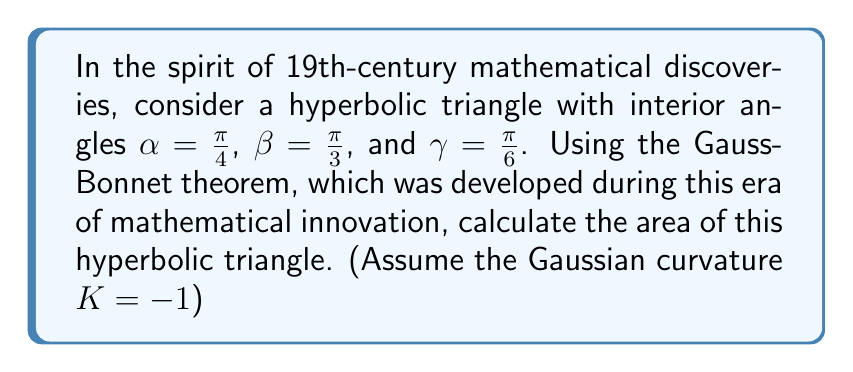Can you answer this question? Let's approach this step-by-step using the Gauss-Bonnet theorem:

1) The Gauss-Bonnet theorem for a hyperbolic triangle states:

   $$A + \alpha + \beta + \gamma = \pi - |K|A$$

   Where $A$ is the area of the triangle, $\alpha$, $\beta$, and $\gamma$ are the interior angles, and $K$ is the Gaussian curvature.

2) We're given that $K = -1$, so our equation becomes:

   $$A + \alpha + \beta + \gamma = \pi + A$$

3) Substituting the given angles:

   $$A + \frac{\pi}{4} + \frac{\pi}{3} + \frac{\pi}{6} = \pi + A$$

4) Simplify the left side:

   $$A + \frac{\pi}{4} + \frac{2\pi}{6} + \frac{\pi}{6} = \pi + A$$
   $$A + \frac{3\pi}{6} + \frac{2\pi}{6} + \frac{\pi}{6} = \pi + A$$
   $$A + \frac{6\pi}{6} = \pi + A$$
   $$A + \pi = \pi + A$$

5) Subtract $A$ from both sides:

   $$\pi = \pi + A - A$$
   $$\pi = \pi$$

6) Subtract $\pi$ from both sides:

   $$0 = 0$$

This result shows that the equation is always true, regardless of the value of $A$. This means we can find $A$ directly from the original Gauss-Bonnet formula:

$$A = \pi - (\alpha + \beta + \gamma)$$

7) Substituting the given angles:

   $$A = \pi - (\frac{\pi}{4} + \frac{\pi}{3} + \frac{\pi}{6})$$
   $$A = \pi - (\frac{3\pi}{12} + \frac{4\pi}{12} + \frac{2\pi}{12})$$
   $$A = \pi - \frac{9\pi}{12}$$
   $$A = \frac{12\pi}{12} - \frac{9\pi}{12}$$
   $$A = \frac{3\pi}{12} = \frac{\pi}{4}$$

Thus, the area of the hyperbolic triangle is $\frac{\pi}{4}$.
Answer: $\frac{\pi}{4}$ 